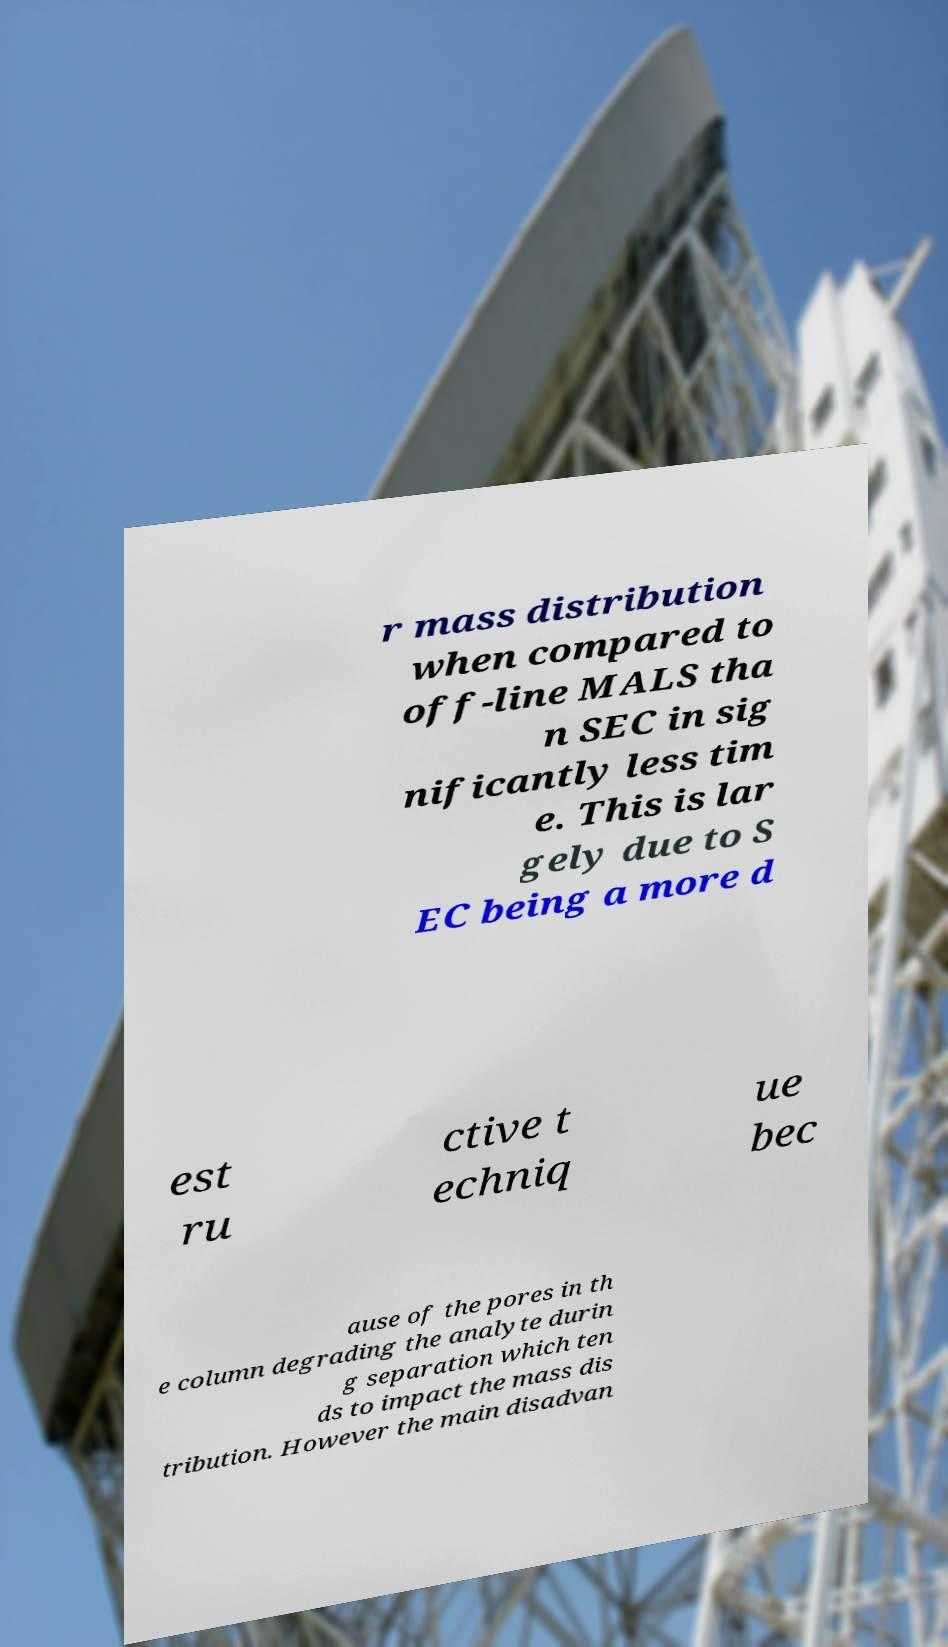Can you accurately transcribe the text from the provided image for me? r mass distribution when compared to off-line MALS tha n SEC in sig nificantly less tim e. This is lar gely due to S EC being a more d est ru ctive t echniq ue bec ause of the pores in th e column degrading the analyte durin g separation which ten ds to impact the mass dis tribution. However the main disadvan 